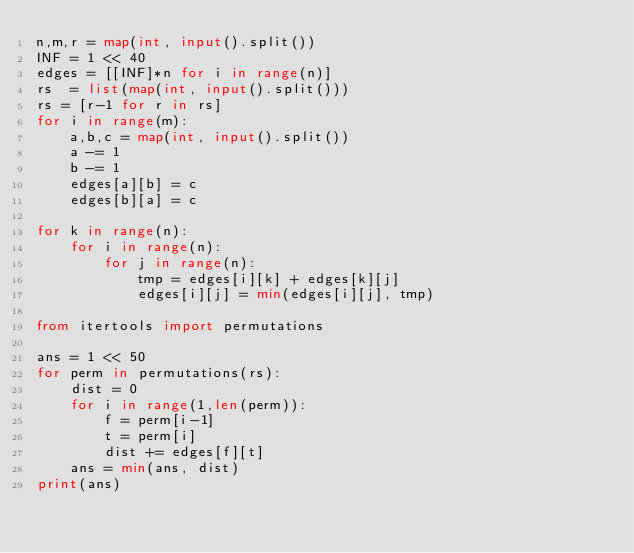<code> <loc_0><loc_0><loc_500><loc_500><_Python_>n,m,r = map(int, input().split())
INF = 1 << 40
edges = [[INF]*n for i in range(n)]
rs  = list(map(int, input().split()))
rs = [r-1 for r in rs]
for i in range(m):
    a,b,c = map(int, input().split())
    a -= 1
    b -= 1
    edges[a][b] = c
    edges[b][a] = c

for k in range(n):
    for i in range(n):
        for j in range(n):
            tmp = edges[i][k] + edges[k][j]
            edges[i][j] = min(edges[i][j], tmp)

from itertools import permutations

ans = 1 << 50
for perm in permutations(rs):
    dist = 0
    for i in range(1,len(perm)):
        f = perm[i-1]
        t = perm[i]
        dist += edges[f][t]
    ans = min(ans, dist)
print(ans)</code> 